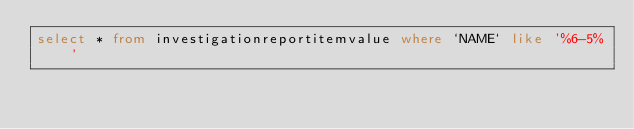Convert code to text. <code><loc_0><loc_0><loc_500><loc_500><_SQL_>select * from investigationreportitemvalue where `NAME` like '%6-5%'</code> 